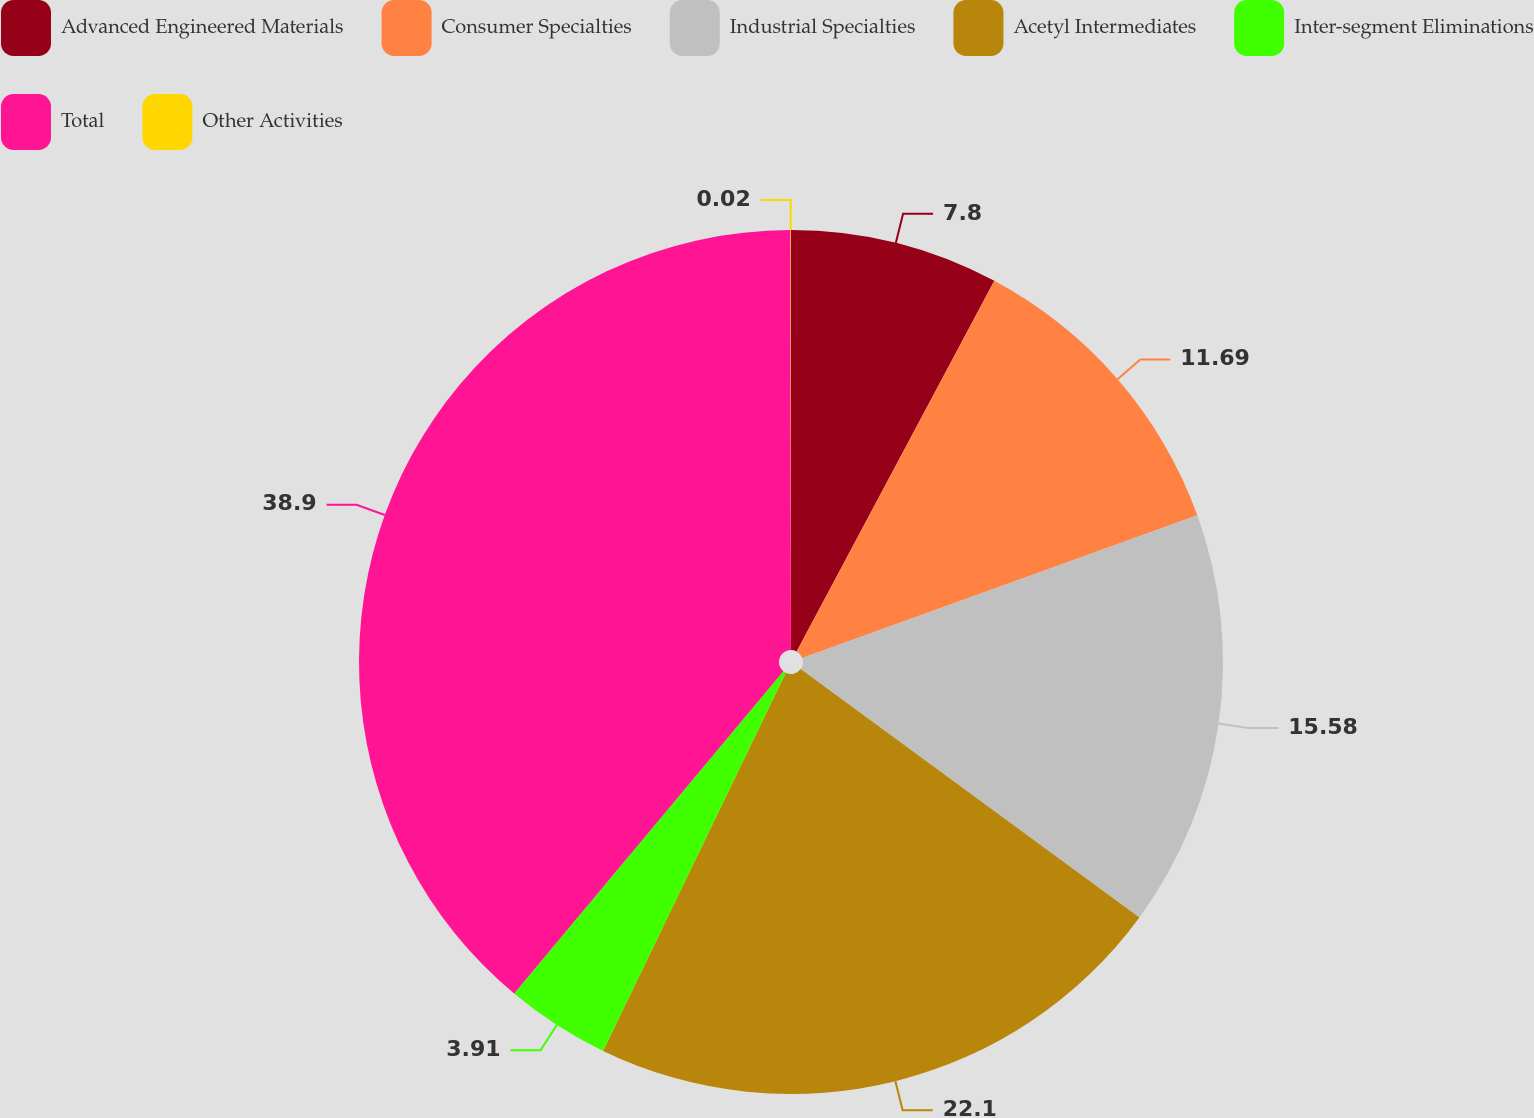Convert chart to OTSL. <chart><loc_0><loc_0><loc_500><loc_500><pie_chart><fcel>Advanced Engineered Materials<fcel>Consumer Specialties<fcel>Industrial Specialties<fcel>Acetyl Intermediates<fcel>Inter-segment Eliminations<fcel>Total<fcel>Other Activities<nl><fcel>7.8%<fcel>11.69%<fcel>15.58%<fcel>22.1%<fcel>3.91%<fcel>38.91%<fcel>0.02%<nl></chart> 